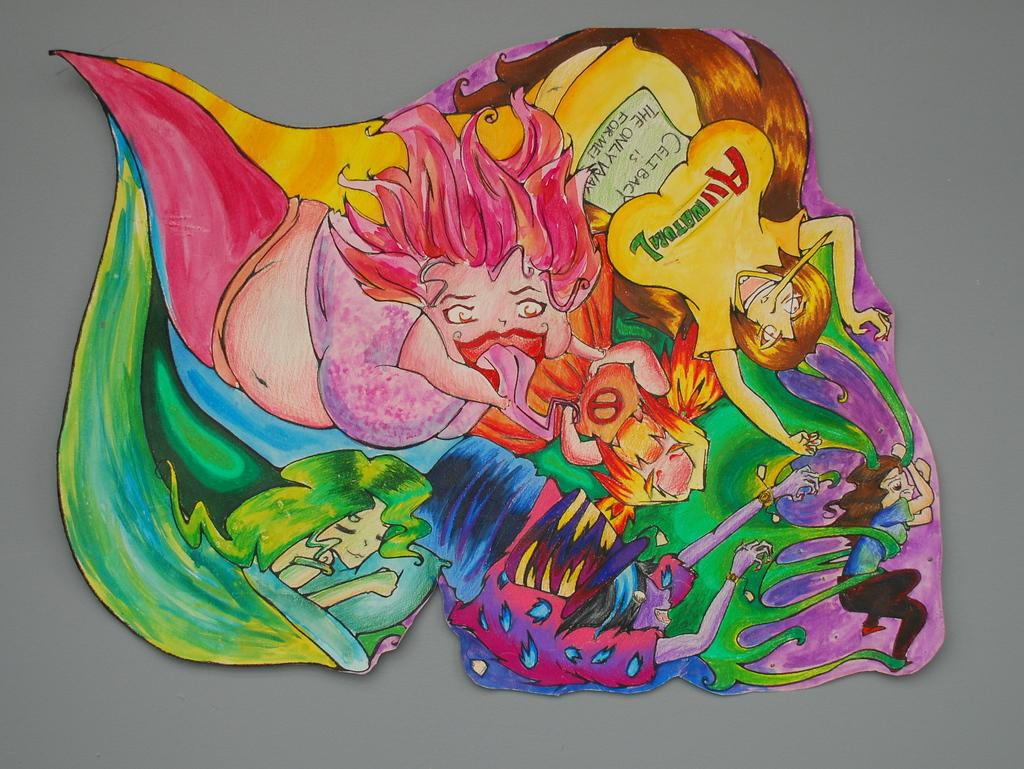What is the main subject of the image? The image contains a painting. Can you describe the painting in the image? The painting has many colors. How does the painting contribute to pollution in the image? There is no indication of pollution in the image, and the painting itself does not contribute to pollution. 